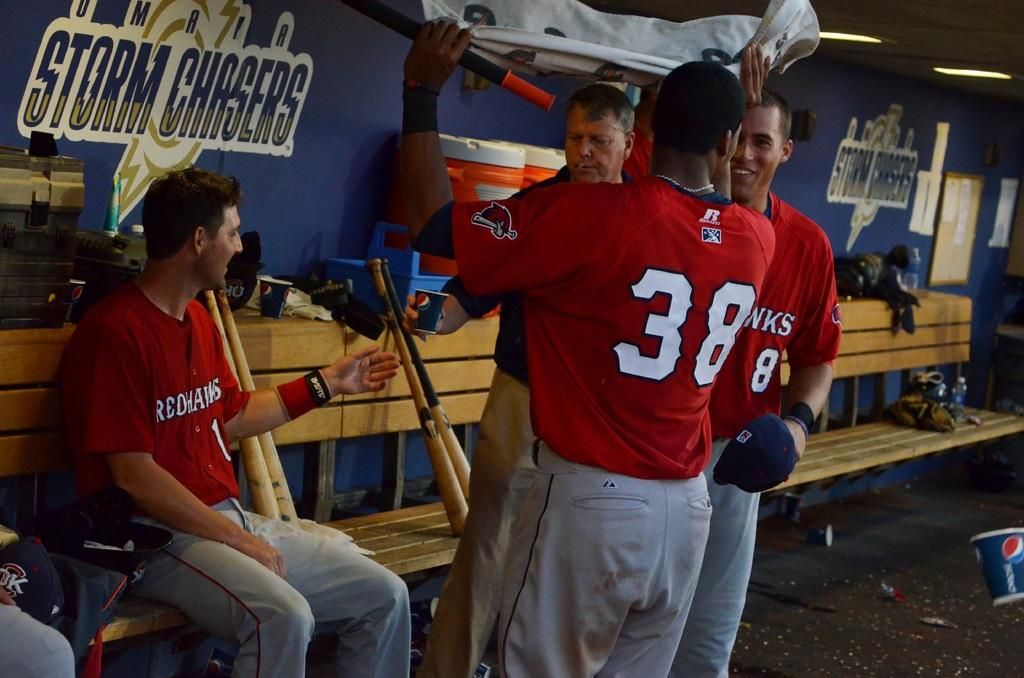Provide a one-sentence caption for the provided image. A man sits on a bench in front of a wall that says "Storm Chasers.". 